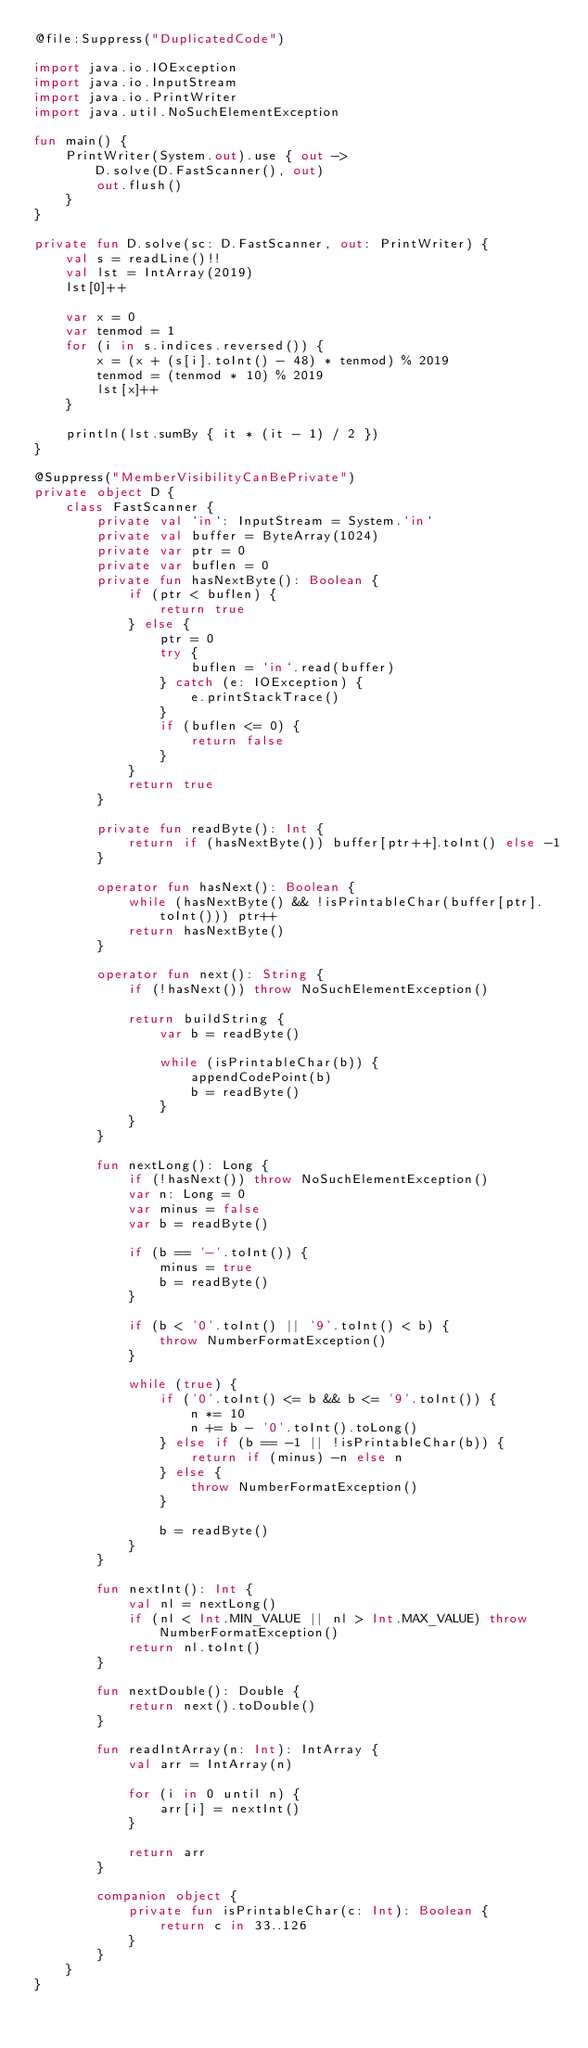<code> <loc_0><loc_0><loc_500><loc_500><_Kotlin_>@file:Suppress("DuplicatedCode")

import java.io.IOException
import java.io.InputStream
import java.io.PrintWriter
import java.util.NoSuchElementException

fun main() {
    PrintWriter(System.out).use { out ->
        D.solve(D.FastScanner(), out)
        out.flush()
    }
}

private fun D.solve(sc: D.FastScanner, out: PrintWriter) {
    val s = readLine()!!
    val lst = IntArray(2019)
    lst[0]++

    var x = 0
    var tenmod = 1
    for (i in s.indices.reversed()) {
        x = (x + (s[i].toInt() - 48) * tenmod) % 2019
        tenmod = (tenmod * 10) % 2019
        lst[x]++
    }

    println(lst.sumBy { it * (it - 1) / 2 })
}

@Suppress("MemberVisibilityCanBePrivate")
private object D {
    class FastScanner {
        private val `in`: InputStream = System.`in`
        private val buffer = ByteArray(1024)
        private var ptr = 0
        private var buflen = 0
        private fun hasNextByte(): Boolean {
            if (ptr < buflen) {
                return true
            } else {
                ptr = 0
                try {
                    buflen = `in`.read(buffer)
                } catch (e: IOException) {
                    e.printStackTrace()
                }
                if (buflen <= 0) {
                    return false
                }
            }
            return true
        }

        private fun readByte(): Int {
            return if (hasNextByte()) buffer[ptr++].toInt() else -1
        }

        operator fun hasNext(): Boolean {
            while (hasNextByte() && !isPrintableChar(buffer[ptr].toInt())) ptr++
            return hasNextByte()
        }

        operator fun next(): String {
            if (!hasNext()) throw NoSuchElementException()

            return buildString {
                var b = readByte()

                while (isPrintableChar(b)) {
                    appendCodePoint(b)
                    b = readByte()
                }
            }
        }

        fun nextLong(): Long {
            if (!hasNext()) throw NoSuchElementException()
            var n: Long = 0
            var minus = false
            var b = readByte()

            if (b == '-'.toInt()) {
                minus = true
                b = readByte()
            }

            if (b < '0'.toInt() || '9'.toInt() < b) {
                throw NumberFormatException()
            }

            while (true) {
                if ('0'.toInt() <= b && b <= '9'.toInt()) {
                    n *= 10
                    n += b - '0'.toInt().toLong()
                } else if (b == -1 || !isPrintableChar(b)) {
                    return if (minus) -n else n
                } else {
                    throw NumberFormatException()
                }

                b = readByte()
            }
        }

        fun nextInt(): Int {
            val nl = nextLong()
            if (nl < Int.MIN_VALUE || nl > Int.MAX_VALUE) throw NumberFormatException()
            return nl.toInt()
        }

        fun nextDouble(): Double {
            return next().toDouble()
        }

        fun readIntArray(n: Int): IntArray {
            val arr = IntArray(n)

            for (i in 0 until n) {
                arr[i] = nextInt()
            }

            return arr
        }

        companion object {
            private fun isPrintableChar(c: Int): Boolean {
                return c in 33..126
            }
        }
    }
}
</code> 